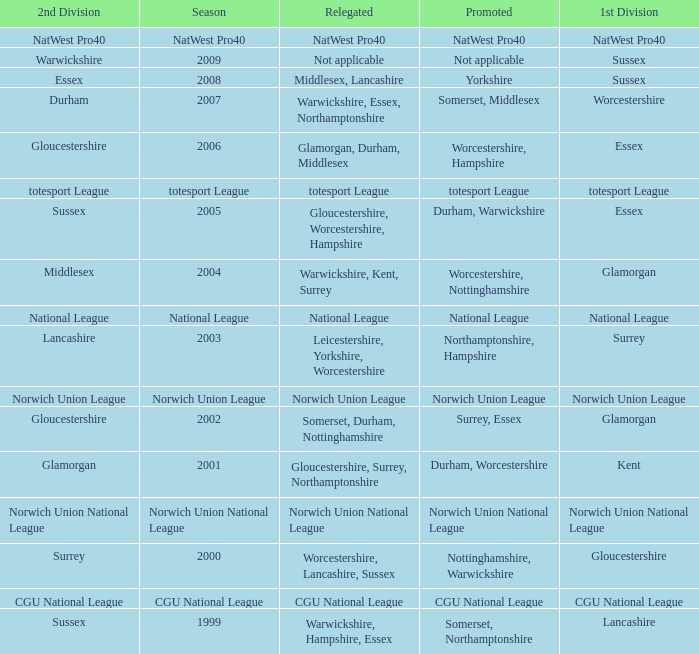What was relegated in the 2nd division of middlesex? Warwickshire, Kent, Surrey. 